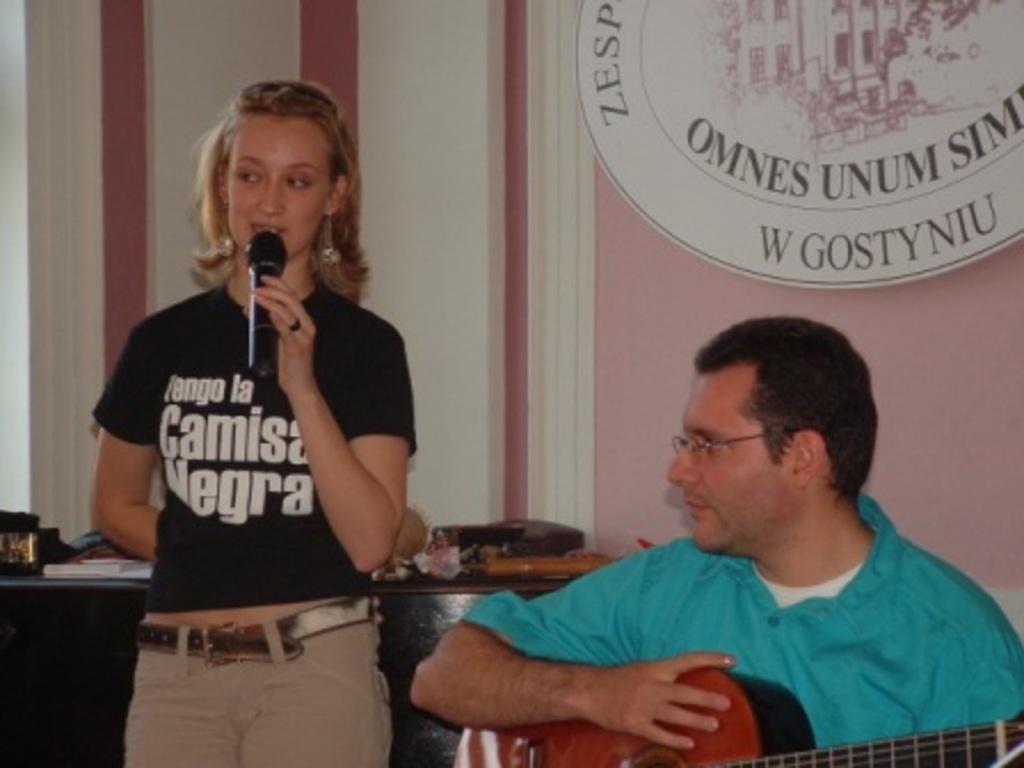What is the woman in the image doing? The woman is standing and holding a microphone. What is the man in the image doing? The man is sitting and holding a guitar in his hand. What objects are the woman and man holding in the image? The woman is holding a microphone, and the man is holding a guitar. How does the woman's belief in the power of heat affect her performance in the image? There is no mention of heat or any beliefs in the image, so it is not possible to answer that question. 